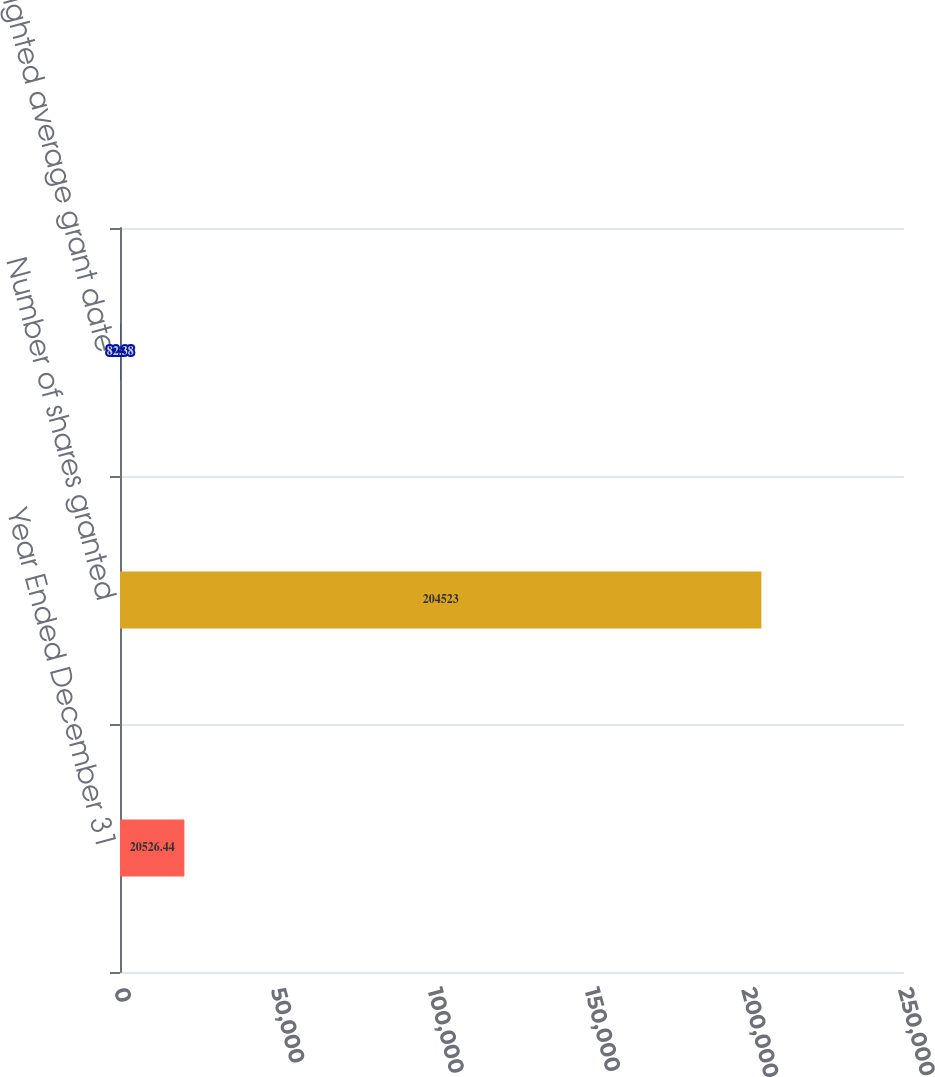Convert chart to OTSL. <chart><loc_0><loc_0><loc_500><loc_500><bar_chart><fcel>Year Ended December 31<fcel>Number of shares granted<fcel>Weighted average grant date<nl><fcel>20526.4<fcel>204523<fcel>82.38<nl></chart> 